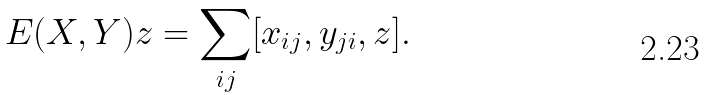<formula> <loc_0><loc_0><loc_500><loc_500>E ( X , Y ) z = \sum _ { i j } [ x _ { i j } , y _ { j i } , z ] .</formula> 